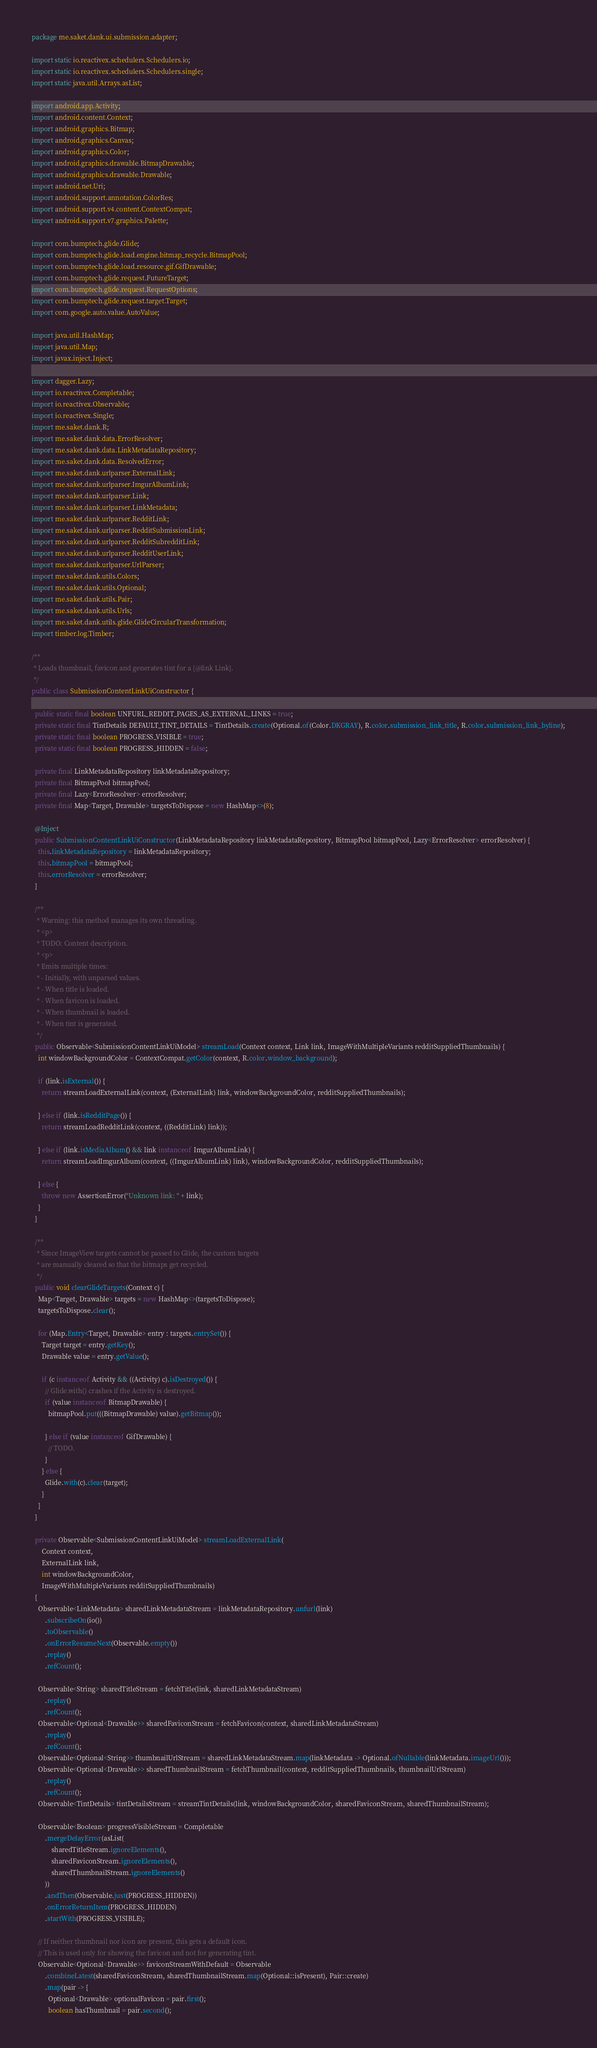Convert code to text. <code><loc_0><loc_0><loc_500><loc_500><_Java_>package me.saket.dank.ui.submission.adapter;

import static io.reactivex.schedulers.Schedulers.io;
import static io.reactivex.schedulers.Schedulers.single;
import static java.util.Arrays.asList;

import android.app.Activity;
import android.content.Context;
import android.graphics.Bitmap;
import android.graphics.Canvas;
import android.graphics.Color;
import android.graphics.drawable.BitmapDrawable;
import android.graphics.drawable.Drawable;
import android.net.Uri;
import android.support.annotation.ColorRes;
import android.support.v4.content.ContextCompat;
import android.support.v7.graphics.Palette;

import com.bumptech.glide.Glide;
import com.bumptech.glide.load.engine.bitmap_recycle.BitmapPool;
import com.bumptech.glide.load.resource.gif.GifDrawable;
import com.bumptech.glide.request.FutureTarget;
import com.bumptech.glide.request.RequestOptions;
import com.bumptech.glide.request.target.Target;
import com.google.auto.value.AutoValue;

import java.util.HashMap;
import java.util.Map;
import javax.inject.Inject;

import dagger.Lazy;
import io.reactivex.Completable;
import io.reactivex.Observable;
import io.reactivex.Single;
import me.saket.dank.R;
import me.saket.dank.data.ErrorResolver;
import me.saket.dank.data.LinkMetadataRepository;
import me.saket.dank.data.ResolvedError;
import me.saket.dank.urlparser.ExternalLink;
import me.saket.dank.urlparser.ImgurAlbumLink;
import me.saket.dank.urlparser.Link;
import me.saket.dank.urlparser.LinkMetadata;
import me.saket.dank.urlparser.RedditLink;
import me.saket.dank.urlparser.RedditSubmissionLink;
import me.saket.dank.urlparser.RedditSubredditLink;
import me.saket.dank.urlparser.RedditUserLink;
import me.saket.dank.urlparser.UrlParser;
import me.saket.dank.utils.Colors;
import me.saket.dank.utils.Optional;
import me.saket.dank.utils.Pair;
import me.saket.dank.utils.Urls;
import me.saket.dank.utils.glide.GlideCircularTransformation;
import timber.log.Timber;

/**
 * Loads thumbnail, favicon and generates tint for a {@link Link}.
 */
public class SubmissionContentLinkUiConstructor {

  public static final boolean UNFURL_REDDIT_PAGES_AS_EXTERNAL_LINKS = true;
  private static final TintDetails DEFAULT_TINT_DETAILS = TintDetails.create(Optional.of(Color.DKGRAY), R.color.submission_link_title, R.color.submission_link_byline);
  private static final boolean PROGRESS_VISIBLE = true;
  private static final boolean PROGRESS_HIDDEN = false;

  private final LinkMetadataRepository linkMetadataRepository;
  private final BitmapPool bitmapPool;
  private final Lazy<ErrorResolver> errorResolver;
  private final Map<Target, Drawable> targetsToDispose = new HashMap<>(8);

  @Inject
  public SubmissionContentLinkUiConstructor(LinkMetadataRepository linkMetadataRepository, BitmapPool bitmapPool, Lazy<ErrorResolver> errorResolver) {
    this.linkMetadataRepository = linkMetadataRepository;
    this.bitmapPool = bitmapPool;
    this.errorResolver = errorResolver;
  }

  /**
   * Warning: this method manages its own threading.
   * <p>
   * TODO: Content description.
   * <p>
   * Emits multiple times:
   * - Initially, with unparsed values.
   * - When title is loaded.
   * - When favicon is loaded.
   * - When thumbnail is loaded.
   * - When tint is generated.
   */
  public Observable<SubmissionContentLinkUiModel> streamLoad(Context context, Link link, ImageWithMultipleVariants redditSuppliedThumbnails) {
    int windowBackgroundColor = ContextCompat.getColor(context, R.color.window_background);

    if (link.isExternal()) {
      return streamLoadExternalLink(context, (ExternalLink) link, windowBackgroundColor, redditSuppliedThumbnails);

    } else if (link.isRedditPage()) {
      return streamLoadRedditLink(context, ((RedditLink) link));

    } else if (link.isMediaAlbum() && link instanceof ImgurAlbumLink) {
      return streamLoadImgurAlbum(context, ((ImgurAlbumLink) link), windowBackgroundColor, redditSuppliedThumbnails);

    } else {
      throw new AssertionError("Unknown link: " + link);
    }
  }

  /**
   * Since ImageView targets cannot be passed to Glide, the custom targets
   * are manually cleared so that the bitmaps get recycled.
   */
  public void clearGlideTargets(Context c) {
    Map<Target, Drawable> targets = new HashMap<>(targetsToDispose);
    targetsToDispose.clear();

    for (Map.Entry<Target, Drawable> entry : targets.entrySet()) {
      Target target = entry.getKey();
      Drawable value = entry.getValue();

      if (c instanceof Activity && ((Activity) c).isDestroyed()) {
        // Glide.with() crashes if the Activity is destroyed.
        if (value instanceof BitmapDrawable) {
          bitmapPool.put(((BitmapDrawable) value).getBitmap());

        } else if (value instanceof GifDrawable) {
          // TODO.
        }
      } else {
        Glide.with(c).clear(target);
      }
    }
  }

  private Observable<SubmissionContentLinkUiModel> streamLoadExternalLink(
      Context context,
      ExternalLink link,
      int windowBackgroundColor,
      ImageWithMultipleVariants redditSuppliedThumbnails)
  {
    Observable<LinkMetadata> sharedLinkMetadataStream = linkMetadataRepository.unfurl(link)
        .subscribeOn(io())
        .toObservable()
        .onErrorResumeNext(Observable.empty())
        .replay()
        .refCount();

    Observable<String> sharedTitleStream = fetchTitle(link, sharedLinkMetadataStream)
        .replay()
        .refCount();
    Observable<Optional<Drawable>> sharedFaviconStream = fetchFavicon(context, sharedLinkMetadataStream)
        .replay()
        .refCount();
    Observable<Optional<String>> thumbnailUrlStream = sharedLinkMetadataStream.map(linkMetadata -> Optional.ofNullable(linkMetadata.imageUrl()));
    Observable<Optional<Drawable>> sharedThumbnailStream = fetchThumbnail(context, redditSuppliedThumbnails, thumbnailUrlStream)
        .replay()
        .refCount();
    Observable<TintDetails> tintDetailsStream = streamTintDetails(link, windowBackgroundColor, sharedFaviconStream, sharedThumbnailStream);

    Observable<Boolean> progressVisibleStream = Completable
        .mergeDelayError(asList(
            sharedTitleStream.ignoreElements(),
            sharedFaviconStream.ignoreElements(),
            sharedThumbnailStream.ignoreElements()
        ))
        .andThen(Observable.just(PROGRESS_HIDDEN))
        .onErrorReturnItem(PROGRESS_HIDDEN)
        .startWith(PROGRESS_VISIBLE);

    // If neither thumbnail nor icon are present, this gets a default icon.
    // This is used only for showing the favicon and not for generating tint.
    Observable<Optional<Drawable>> faviconStreamWithDefault = Observable
        .combineLatest(sharedFaviconStream, sharedThumbnailStream.map(Optional::isPresent), Pair::create)
        .map(pair -> {
          Optional<Drawable> optionalFavicon = pair.first();
          boolean hasThumbnail = pair.second();
</code> 